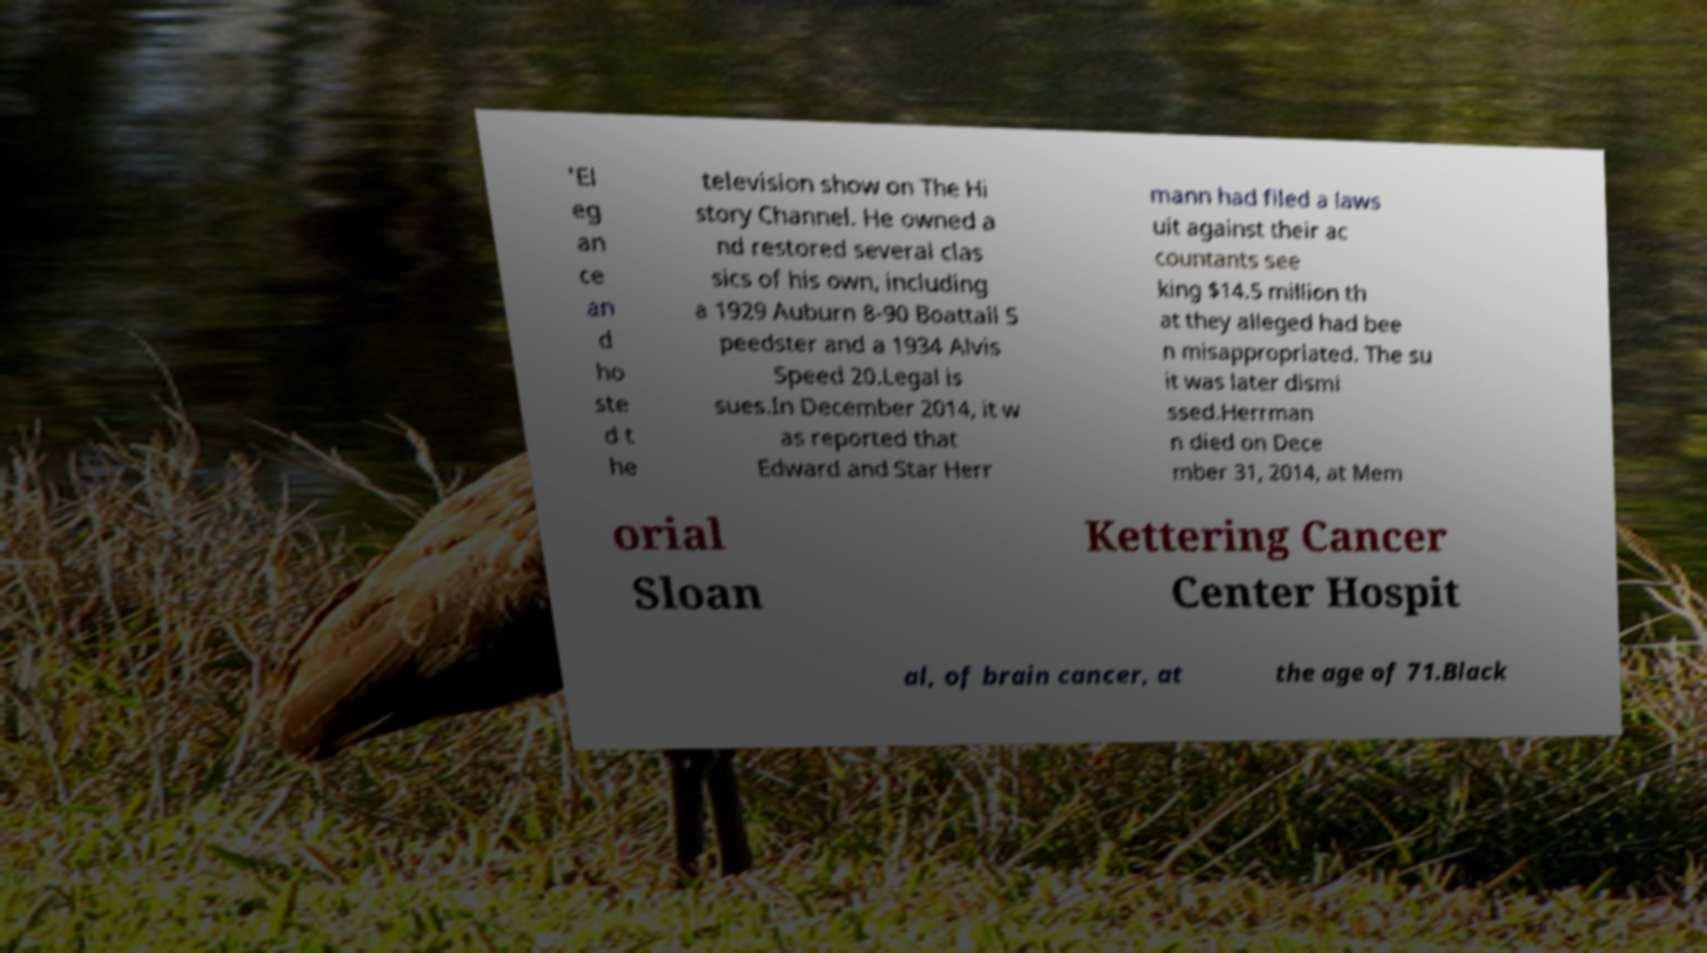I need the written content from this picture converted into text. Can you do that? 'El eg an ce an d ho ste d t he television show on The Hi story Channel. He owned a nd restored several clas sics of his own, including a 1929 Auburn 8-90 Boattail S peedster and a 1934 Alvis Speed 20.Legal is sues.In December 2014, it w as reported that Edward and Star Herr mann had filed a laws uit against their ac countants see king $14.5 million th at they alleged had bee n misappropriated. The su it was later dismi ssed.Herrman n died on Dece mber 31, 2014, at Mem orial Sloan Kettering Cancer Center Hospit al, of brain cancer, at the age of 71.Black 